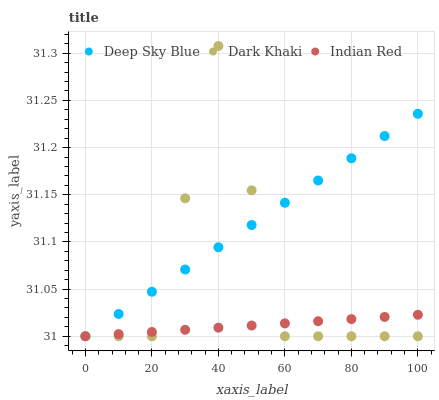Does Indian Red have the minimum area under the curve?
Answer yes or no. Yes. Does Deep Sky Blue have the maximum area under the curve?
Answer yes or no. Yes. Does Deep Sky Blue have the minimum area under the curve?
Answer yes or no. No. Does Indian Red have the maximum area under the curve?
Answer yes or no. No. Is Indian Red the smoothest?
Answer yes or no. Yes. Is Dark Khaki the roughest?
Answer yes or no. Yes. Is Deep Sky Blue the smoothest?
Answer yes or no. No. Is Deep Sky Blue the roughest?
Answer yes or no. No. Does Dark Khaki have the lowest value?
Answer yes or no. Yes. Does Dark Khaki have the highest value?
Answer yes or no. Yes. Does Deep Sky Blue have the highest value?
Answer yes or no. No. Does Deep Sky Blue intersect Dark Khaki?
Answer yes or no. Yes. Is Deep Sky Blue less than Dark Khaki?
Answer yes or no. No. Is Deep Sky Blue greater than Dark Khaki?
Answer yes or no. No. 